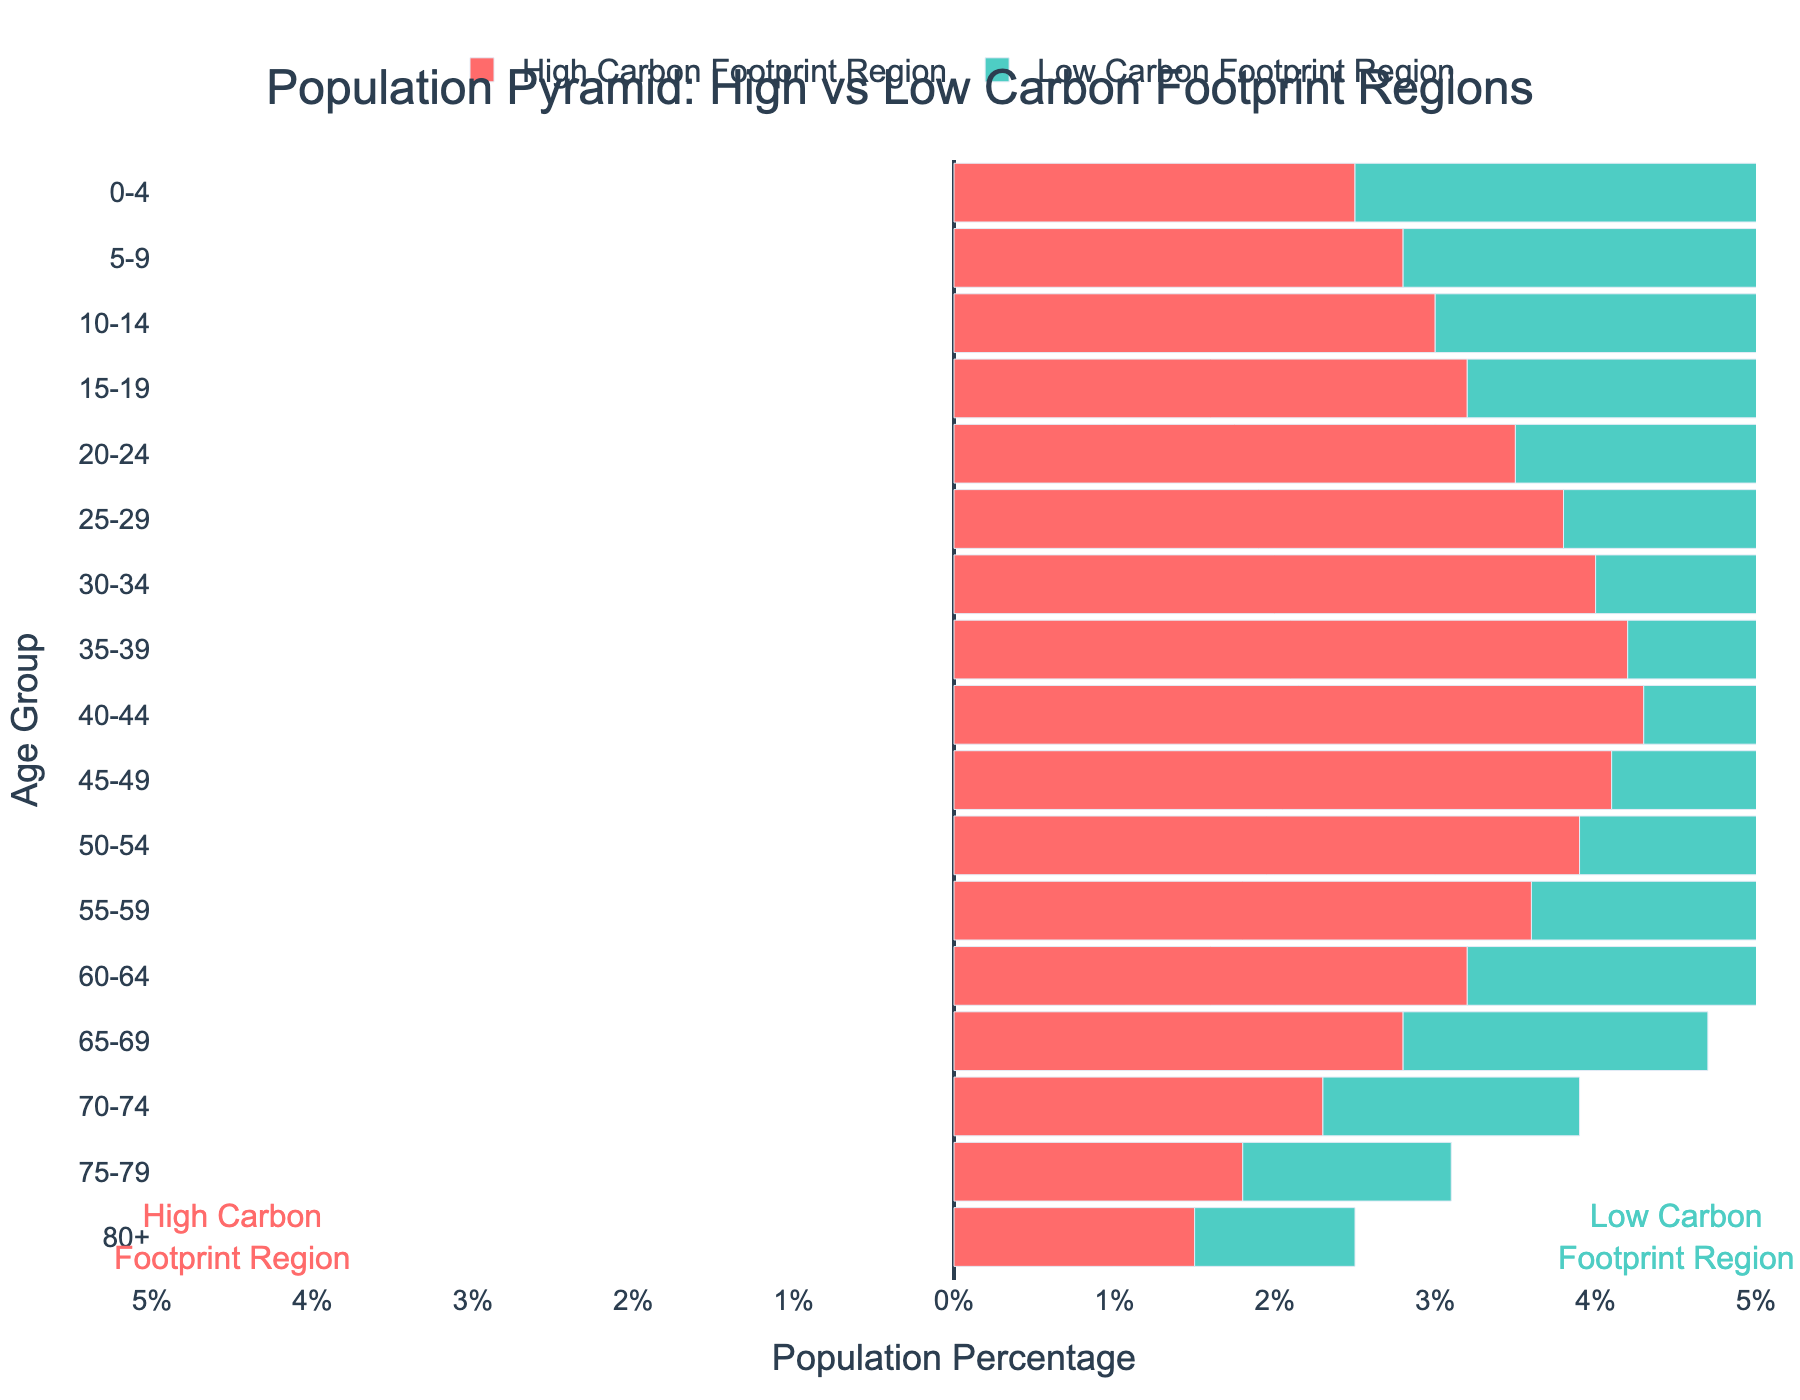what is the title of the plot? The title of the plot is written at the top and reads 'Population Pyramid: High vs Low Carbon Footprint Regions'.
Answer: Population Pyramid: High vs Low Carbon Footprint Regions What are the axis titles in the plot? The x-axis title is 'Population Percentage', and the y-axis title is 'Age Group'. These titles are located along the respective axes.
Answer: Population Percentage (x-axis) and Age Group (y-axis) What color represents the Low Carbon Footprint Region? The Low Carbon Footprint Region is represented by a cyan-like color, which is shown in the legend and in the bars of the plot.
Answer: Cyan Which age group has the largest population percentage in the High Carbon Footprint Region? By examining the length of the bars, the age group 40-44 has the longest bar on the High Carbon Footprint Region side.
Answer: 40-44 How does the population of the 10-14 age group compare between high and low carbon footprint regions? The bar for the 10-14 age group in the low carbon footprint region is taller (3.6%) compared to the same age group in the high carbon footprint region (3.0%).
Answer: Lower in the high carbon footprint region What can be inferred about the population trend in the Low Carbon Footprint Region as the age increases? As age increases, the population percentage in the Low Carbon Footprint Region decreases, with a gradual decrease in bar length from younger to older age groups.
Answer: Decreasing trend Calculate the difference in population percentage between the High and Low Carbon Footprint Regions for the 20-24 age group. The population percentage for the 20-24 age group is 3.5% in the high carbon footprint region and 4.0% in the low carbon footprint region. Subtract 3.5% from 4.0%.
Answer: 0.5% What is the overall difference in population percentage trend between the two regions? The High Carbon Footprint Region shows a high percentage for younger age groups with a sharp decline as age increases, while the Low Carbon Footprint Region shows a high percentage for younger age groups but maintains a less steep decrease as age increases.
Answer: Steeper decline in high carbon region What percentage of the 5-9 age group belongs to the Low Carbon Footprint Region? The bar for the 5-9 age group on the Low Carbon Footprint side indicates a population percentage of 3.4%.
Answer: 3.4% 